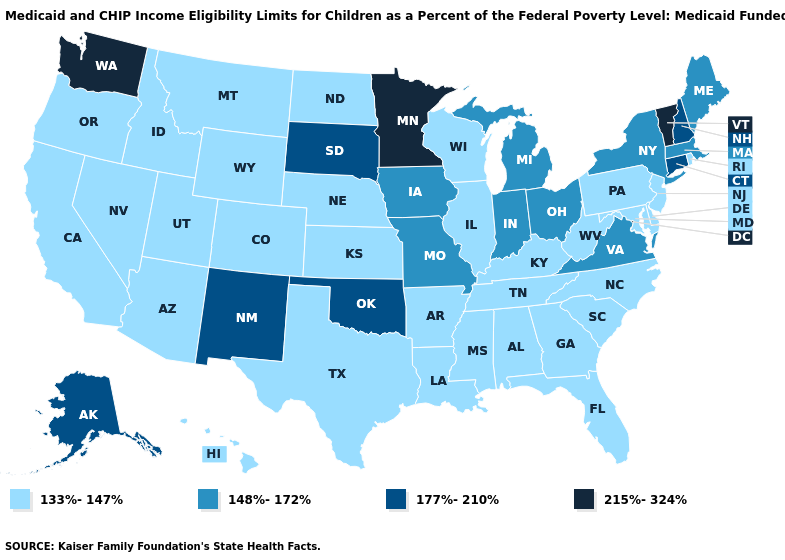Which states have the highest value in the USA?
Give a very brief answer. Minnesota, Vermont, Washington. What is the lowest value in the USA?
Concise answer only. 133%-147%. What is the value of Illinois?
Quick response, please. 133%-147%. Which states have the lowest value in the USA?
Be succinct. Alabama, Arizona, Arkansas, California, Colorado, Delaware, Florida, Georgia, Hawaii, Idaho, Illinois, Kansas, Kentucky, Louisiana, Maryland, Mississippi, Montana, Nebraska, Nevada, New Jersey, North Carolina, North Dakota, Oregon, Pennsylvania, Rhode Island, South Carolina, Tennessee, Texas, Utah, West Virginia, Wisconsin, Wyoming. Which states hav the highest value in the West?
Concise answer only. Washington. Does the first symbol in the legend represent the smallest category?
Quick response, please. Yes. What is the value of Illinois?
Keep it brief. 133%-147%. What is the value of Iowa?
Quick response, please. 148%-172%. Does the first symbol in the legend represent the smallest category?
Give a very brief answer. Yes. What is the lowest value in the USA?
Concise answer only. 133%-147%. Among the states that border Minnesota , does Iowa have the lowest value?
Short answer required. No. Name the states that have a value in the range 133%-147%?
Short answer required. Alabama, Arizona, Arkansas, California, Colorado, Delaware, Florida, Georgia, Hawaii, Idaho, Illinois, Kansas, Kentucky, Louisiana, Maryland, Mississippi, Montana, Nebraska, Nevada, New Jersey, North Carolina, North Dakota, Oregon, Pennsylvania, Rhode Island, South Carolina, Tennessee, Texas, Utah, West Virginia, Wisconsin, Wyoming. Which states hav the highest value in the Northeast?
Be succinct. Vermont. Name the states that have a value in the range 177%-210%?
Short answer required. Alaska, Connecticut, New Hampshire, New Mexico, Oklahoma, South Dakota. 